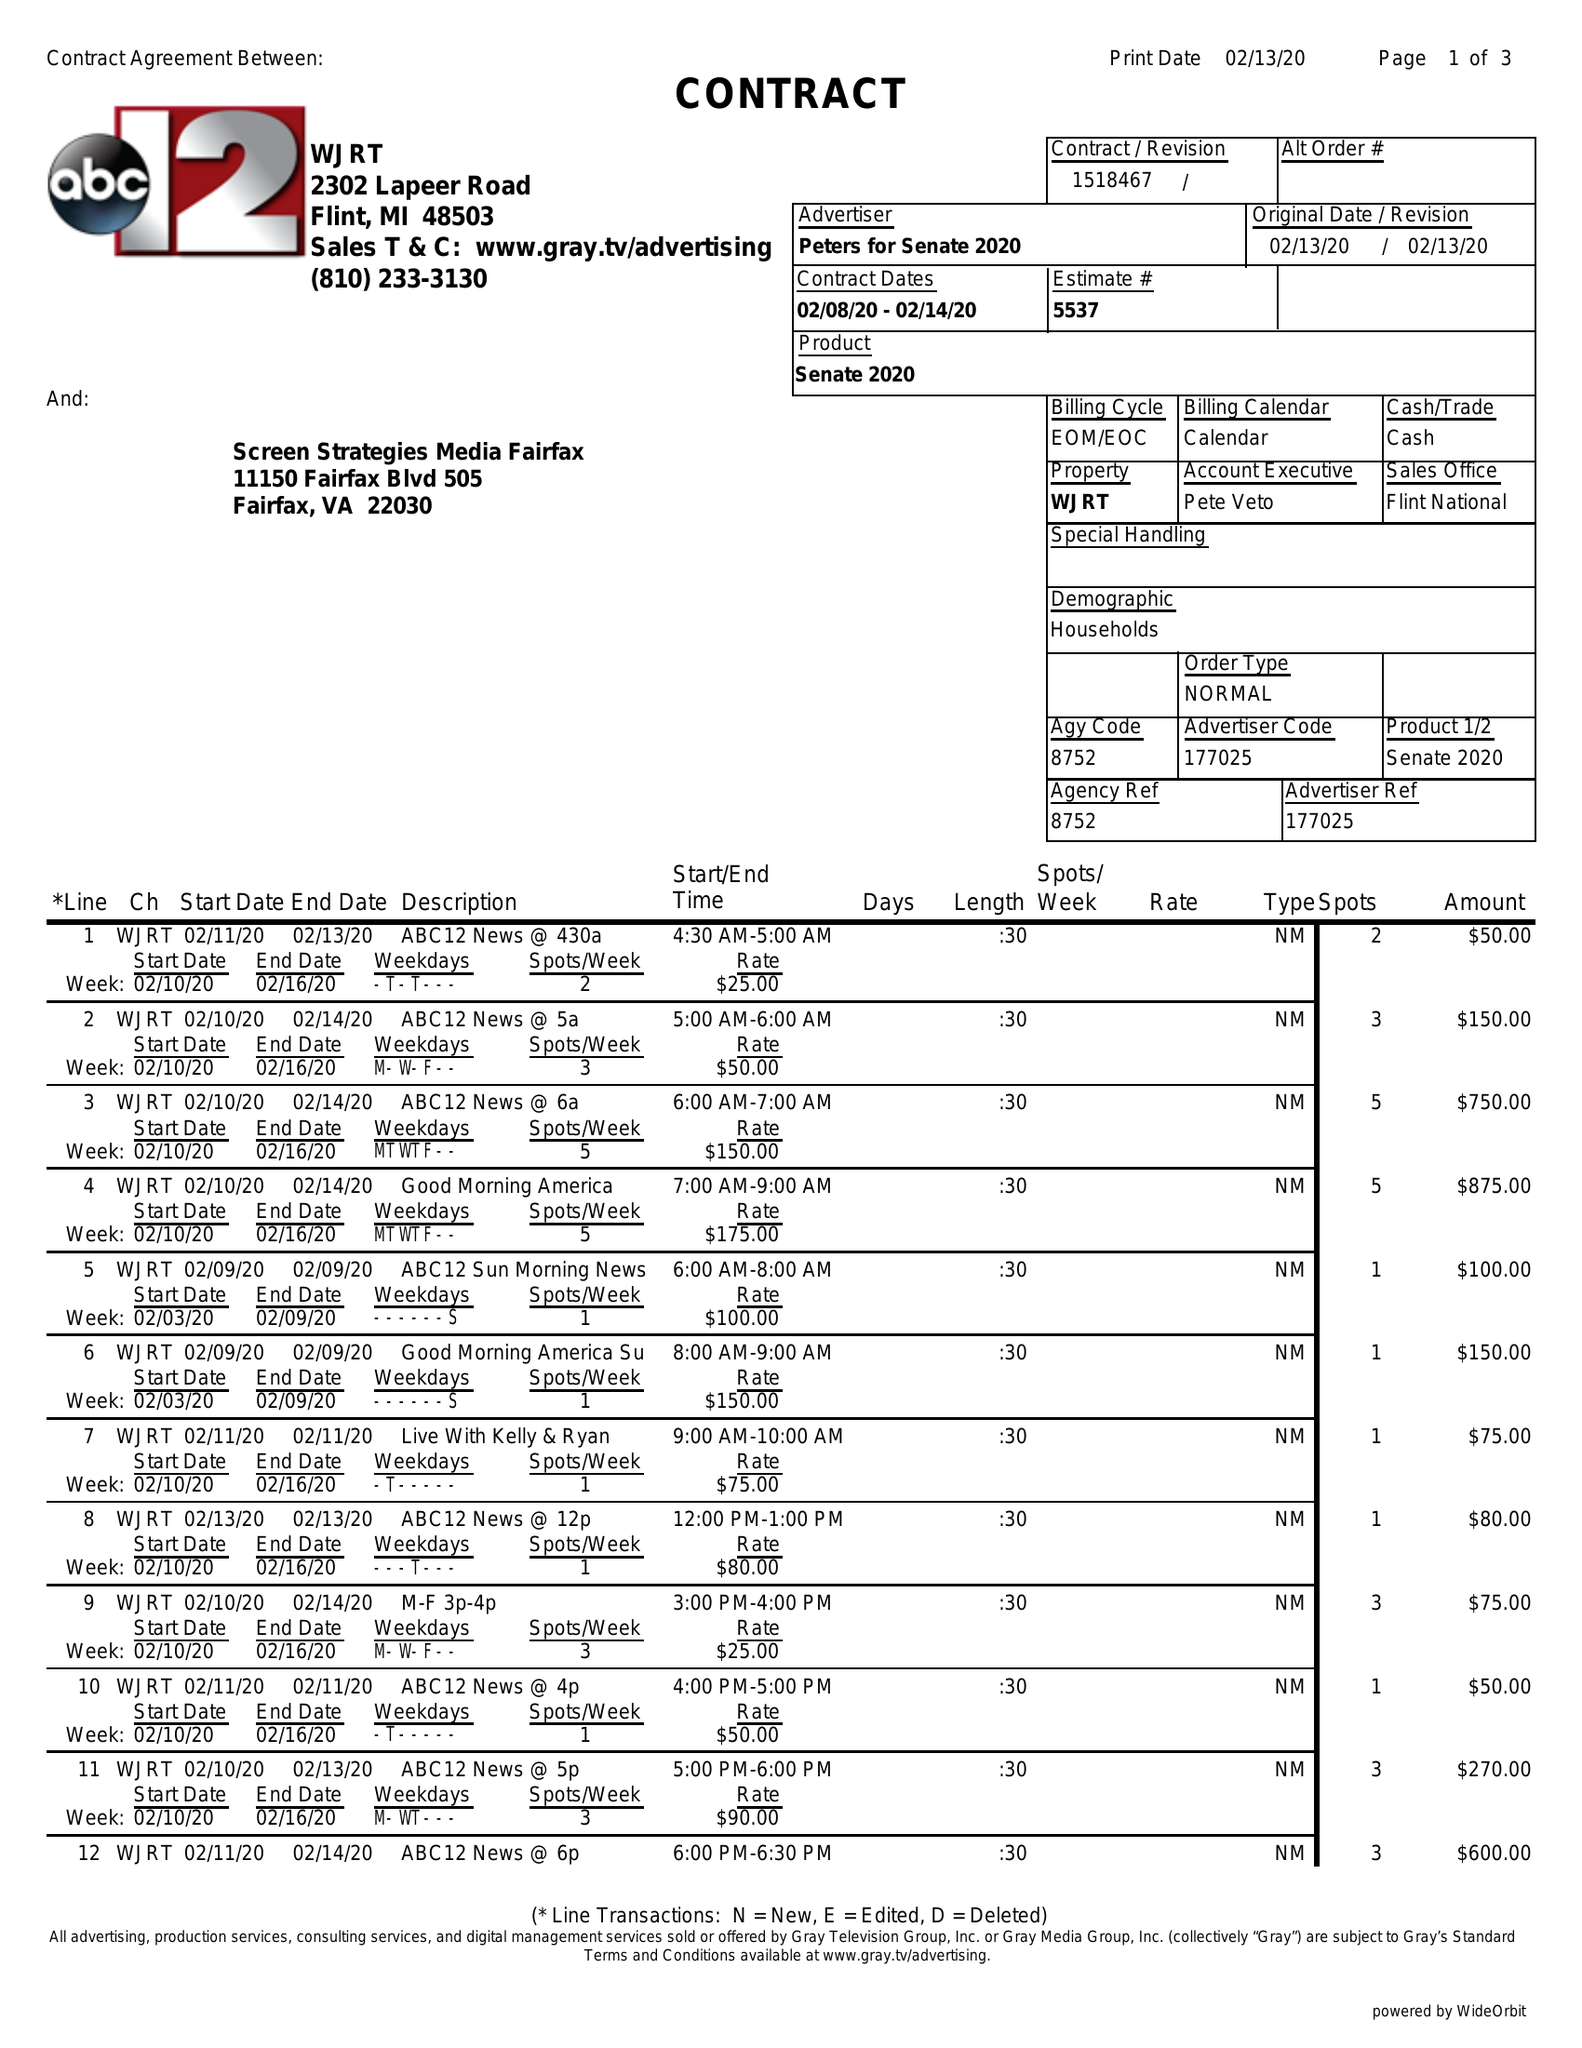What is the value for the flight_from?
Answer the question using a single word or phrase. 02/08/20 